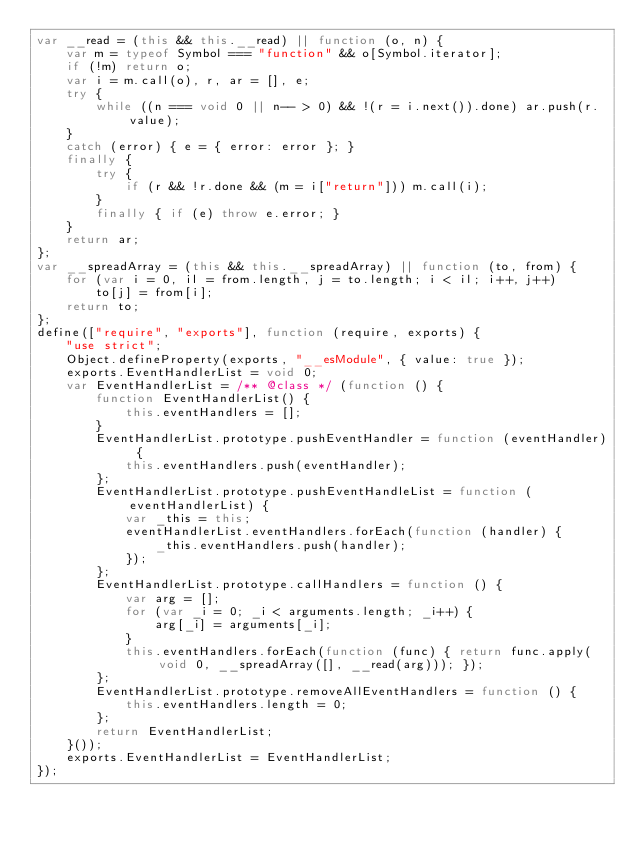Convert code to text. <code><loc_0><loc_0><loc_500><loc_500><_JavaScript_>var __read = (this && this.__read) || function (o, n) {
    var m = typeof Symbol === "function" && o[Symbol.iterator];
    if (!m) return o;
    var i = m.call(o), r, ar = [], e;
    try {
        while ((n === void 0 || n-- > 0) && !(r = i.next()).done) ar.push(r.value);
    }
    catch (error) { e = { error: error }; }
    finally {
        try {
            if (r && !r.done && (m = i["return"])) m.call(i);
        }
        finally { if (e) throw e.error; }
    }
    return ar;
};
var __spreadArray = (this && this.__spreadArray) || function (to, from) {
    for (var i = 0, il = from.length, j = to.length; i < il; i++, j++)
        to[j] = from[i];
    return to;
};
define(["require", "exports"], function (require, exports) {
    "use strict";
    Object.defineProperty(exports, "__esModule", { value: true });
    exports.EventHandlerList = void 0;
    var EventHandlerList = /** @class */ (function () {
        function EventHandlerList() {
            this.eventHandlers = [];
        }
        EventHandlerList.prototype.pushEventHandler = function (eventHandler) {
            this.eventHandlers.push(eventHandler);
        };
        EventHandlerList.prototype.pushEventHandleList = function (eventHandlerList) {
            var _this = this;
            eventHandlerList.eventHandlers.forEach(function (handler) {
                _this.eventHandlers.push(handler);
            });
        };
        EventHandlerList.prototype.callHandlers = function () {
            var arg = [];
            for (var _i = 0; _i < arguments.length; _i++) {
                arg[_i] = arguments[_i];
            }
            this.eventHandlers.forEach(function (func) { return func.apply(void 0, __spreadArray([], __read(arg))); });
        };
        EventHandlerList.prototype.removeAllEventHandlers = function () {
            this.eventHandlers.length = 0;
        };
        return EventHandlerList;
    }());
    exports.EventHandlerList = EventHandlerList;
});
</code> 